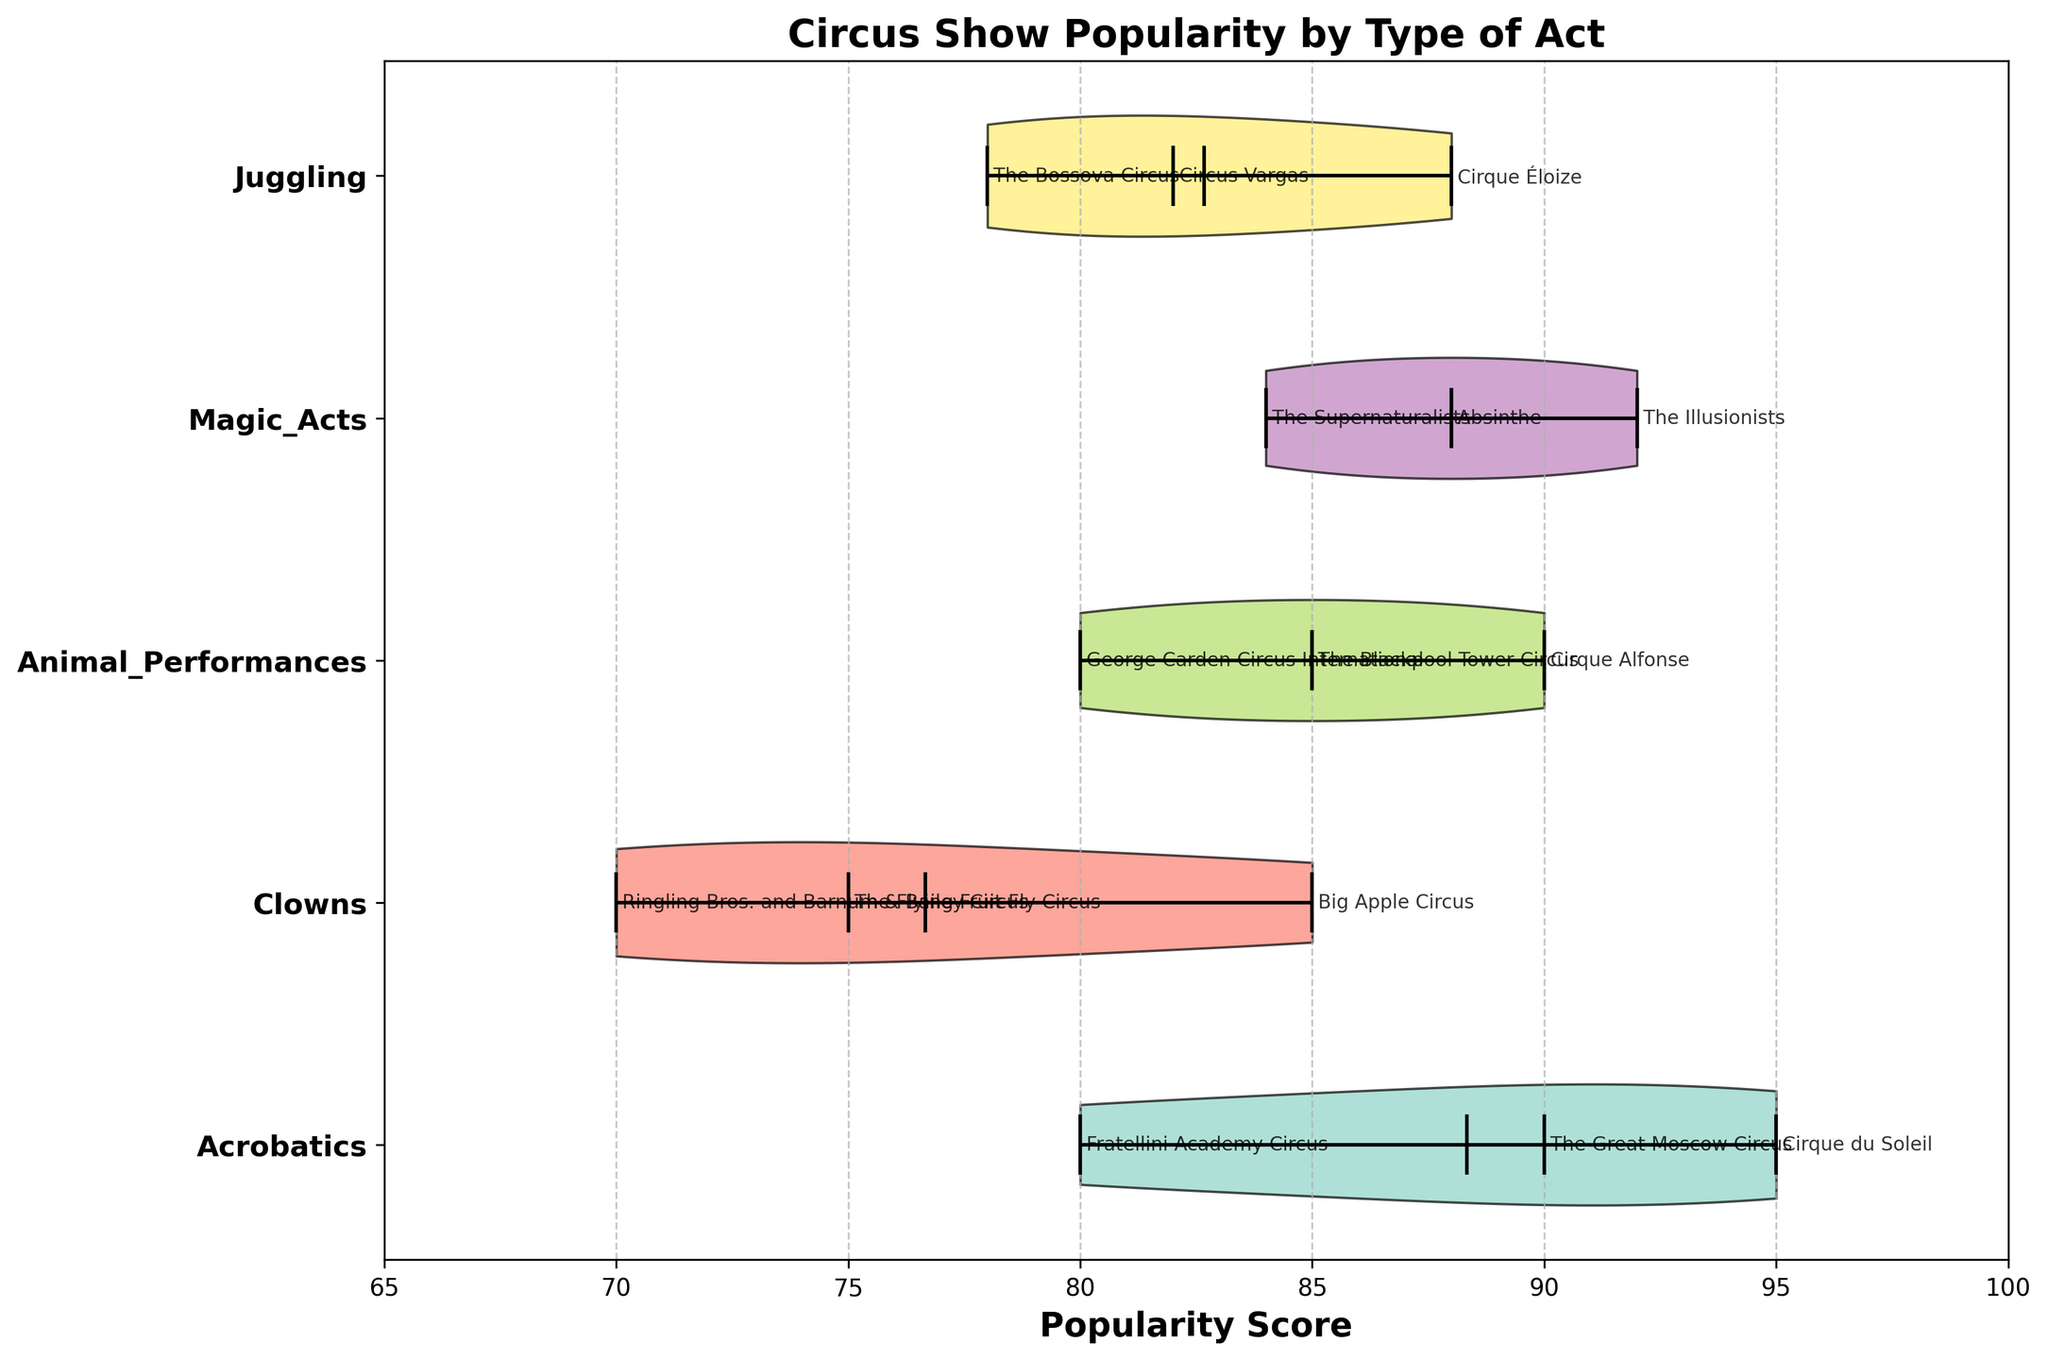What type of acts are represented in the chart? The y-axis of the chart lists the types of acts represented in the circus shows. These are Acrobatics, Clowns, Animal Performances, Magic Acts, and Juggling.
Answer: Acrobatics, Clowns, Animal Performances, Magic Acts, Juggling Which type of act has the highest median popularity score? The median values are indicated by the thicker line within each violin. The violin for Acrobatics has the highest central line, representing the highest median popularity score.
Answer: Acrobatics What is the median popularity score of Magic Acts? The thicker line in the Magic Acts violin plot indicates the median value. This line is positioned at the score of 88.
Answer: 88 Which act type has the most variable popularity scores? The act type with the widest violin plot horizontally indicates the most variability. Clowns have the widest plot, showing the most variability in popularity scores.
Answer: Clowns Which show scored the highest popularity score and under which act type? Cirque du Soleil, under the act type Acrobatics, has the highest popularity score of 95.
Answer: Cirque du Soleil, Acrobatics Compare the median popularity scores of Animal Performances and Juggling acts. Which one is higher? By comparing the thicker lines (medians) within the Animal Performances and Juggling violins, it is clear that the median of Animal Performances is higher than Juggling.
Answer: Animal Performances What are the popularity score ranges for Clowns? The endpoints of the Clowns' violin plot represent the minimum and maximum scores. The range stretches from 70 to 85.
Answer: 70 to 85 Between Juggling and Magic Acts, which has a lower mean popularity score? The circular markers within each plot indicate the mean values. The mean of Juggling is visually lower than that of Magic Acts.
Answer: Juggling Which act type has the smallest interquartile range (middle 50% of data)? The narrowest width in the center part of a violin plot indicates the smallest interquartile range. Animal Performances have the thinnest middle, indicating the smallest interquartile range.
Answer: Animal Performances What is the range of popularity scores for Acrobatics? The horizontal span of the Acrobatics violin shows the range from 80 to 95.
Answer: 80 to 95 